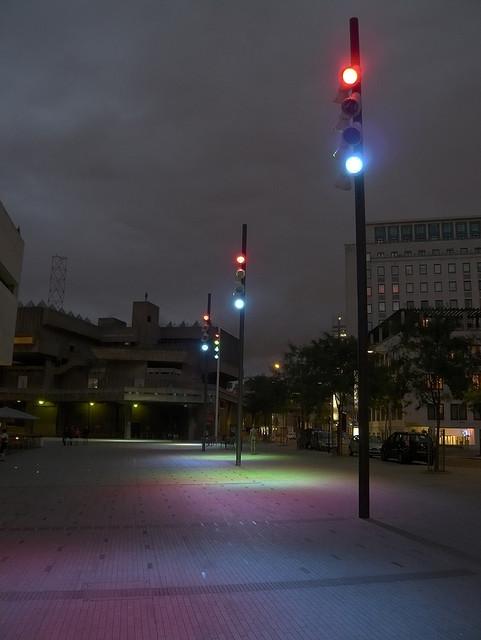What time of day is it?
Be succinct. Night. How many stop lights are there?
Concise answer only. 3. How many street lights are there?
Be succinct. 3. Where is this intersection?
Be succinct. City. Did it rain some time during the day or night?
Give a very brief answer. No. What color is the light?
Keep it brief. Red and green. Are there any trees in this photo?
Short answer required. Yes. Where is the train?
Short answer required. Nowhere. What color is the traffic light?
Concise answer only. Green. How many lights are red?
Answer briefly. 3. 